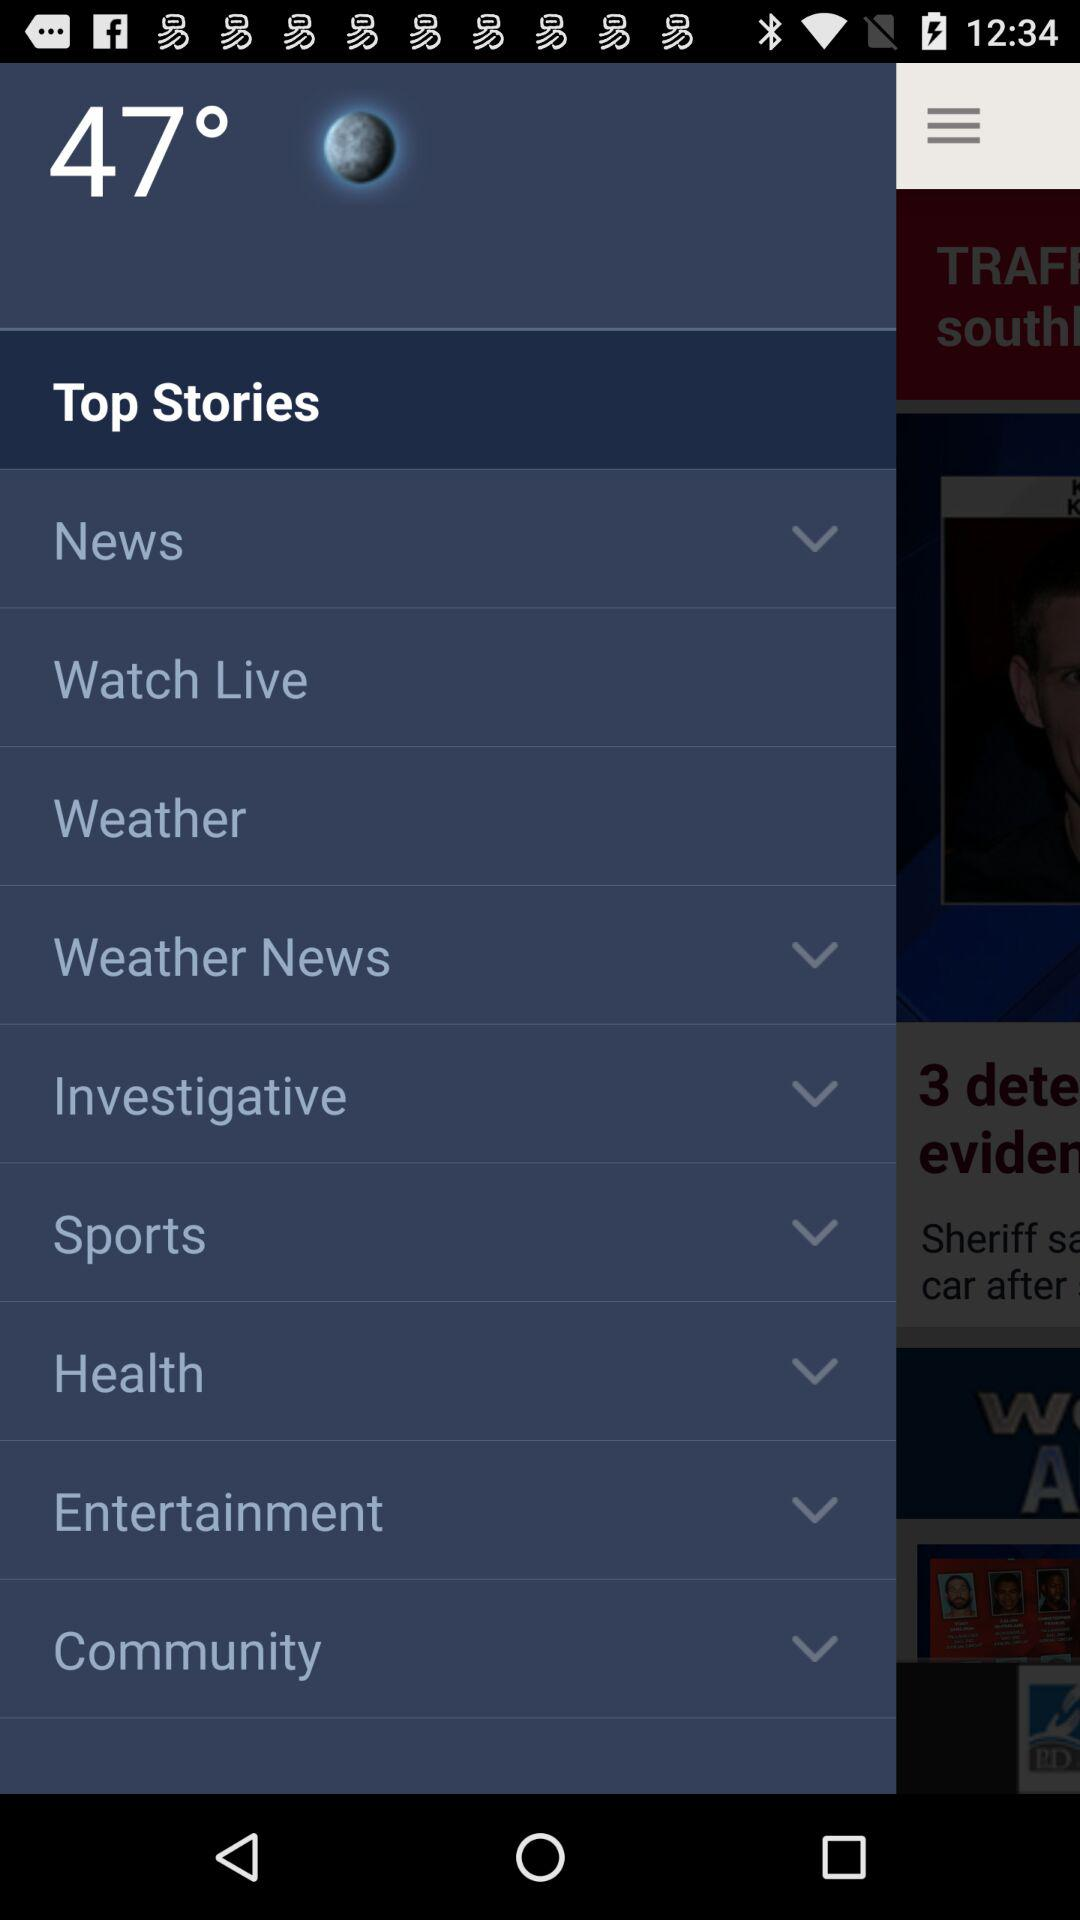What is the temperature? The temperature is 47°. 